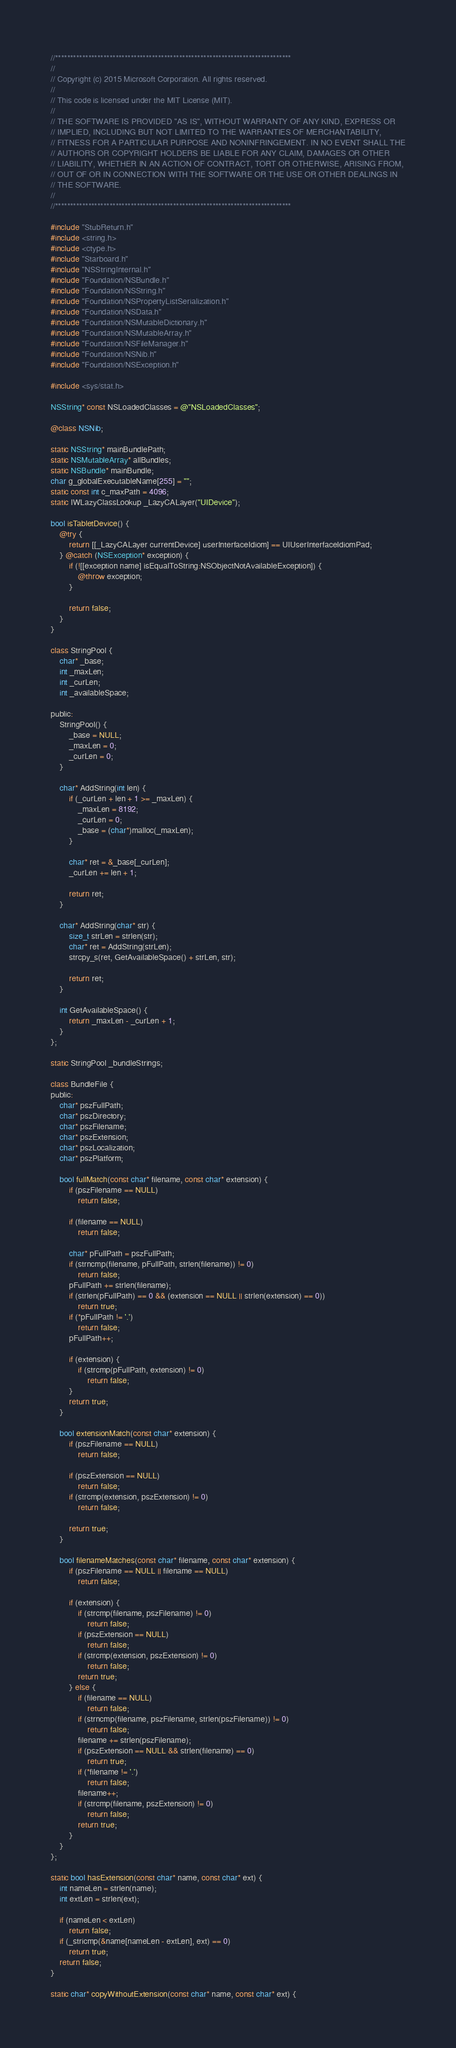Convert code to text. <code><loc_0><loc_0><loc_500><loc_500><_ObjectiveC_>//******************************************************************************
//
// Copyright (c) 2015 Microsoft Corporation. All rights reserved.
//
// This code is licensed under the MIT License (MIT).
//
// THE SOFTWARE IS PROVIDED "AS IS", WITHOUT WARRANTY OF ANY KIND, EXPRESS OR
// IMPLIED, INCLUDING BUT NOT LIMITED TO THE WARRANTIES OF MERCHANTABILITY,
// FITNESS FOR A PARTICULAR PURPOSE AND NONINFRINGEMENT. IN NO EVENT SHALL THE
// AUTHORS OR COPYRIGHT HOLDERS BE LIABLE FOR ANY CLAIM, DAMAGES OR OTHER
// LIABILITY, WHETHER IN AN ACTION OF CONTRACT, TORT OR OTHERWISE, ARISING FROM,
// OUT OF OR IN CONNECTION WITH THE SOFTWARE OR THE USE OR OTHER DEALINGS IN
// THE SOFTWARE.
//
//******************************************************************************

#include "StubReturn.h"
#include <string.h>
#include <ctype.h>
#include "Starboard.h"
#include "NSStringInternal.h"
#include "Foundation/NSBundle.h"
#include "Foundation/NSString.h"
#include "Foundation/NSPropertyListSerialization.h"
#include "Foundation/NSData.h"
#include "Foundation/NSMutableDictionary.h"
#include "Foundation/NSMutableArray.h"
#include "Foundation/NSFileManager.h"
#include "Foundation/NSNib.h"
#include "Foundation/NSException.h"

#include <sys/stat.h>

NSString* const NSLoadedClasses = @"NSLoadedClasses";

@class NSNib;

static NSString* mainBundlePath;
static NSMutableArray* allBundles;
static NSBundle* mainBundle;
char g_globalExecutableName[255] = "";
static const int c_maxPath = 4096;
static IWLazyClassLookup _LazyCALayer("UIDevice");

bool isTabletDevice() {
    @try {
        return [[_LazyCALayer currentDevice] userInterfaceIdiom] == UIUserInterfaceIdiomPad;
    } @catch (NSException* exception) {
        if (![[exception name] isEqualToString:NSObjectNotAvailableException]) {
            @throw exception;
        }

        return false;
    }
}

class StringPool {
    char* _base;
    int _maxLen;
    int _curLen;
    int _availableSpace;

public:
    StringPool() {
        _base = NULL;
        _maxLen = 0;
        _curLen = 0;
    }

    char* AddString(int len) {
        if (_curLen + len + 1 >= _maxLen) {
            _maxLen = 8192;
            _curLen = 0;
            _base = (char*)malloc(_maxLen);
        }

        char* ret = &_base[_curLen];
        _curLen += len + 1;

        return ret;
    }

    char* AddString(char* str) {
        size_t strLen = strlen(str);
        char* ret = AddString(strLen);
        strcpy_s(ret, GetAvailableSpace() + strLen, str);

        return ret;
    }

    int GetAvailableSpace() {
        return _maxLen - _curLen + 1;
    }
};

static StringPool _bundleStrings;

class BundleFile {
public:
    char* pszFullPath;
    char* pszDirectory;
    char* pszFilename;
    char* pszExtension;
    char* pszLocalization;
    char* pszPlatform;

    bool fullMatch(const char* filename, const char* extension) {
        if (pszFilename == NULL)
            return false;

        if (filename == NULL)
            return false;

        char* pFullPath = pszFullPath;
        if (strncmp(filename, pFullPath, strlen(filename)) != 0)
            return false;
        pFullPath += strlen(filename);
        if (strlen(pFullPath) == 0 && (extension == NULL || strlen(extension) == 0))
            return true;
        if (*pFullPath != '.')
            return false;
        pFullPath++;

        if (extension) {
            if (strcmp(pFullPath, extension) != 0)
                return false;
        }
        return true;
    }

    bool extensionMatch(const char* extension) {
        if (pszFilename == NULL)
            return false;

        if (pszExtension == NULL)
            return false;
        if (strcmp(extension, pszExtension) != 0)
            return false;

        return true;
    }

    bool filenameMatches(const char* filename, const char* extension) {
        if (pszFilename == NULL || filename == NULL)
            return false;

        if (extension) {
            if (strcmp(filename, pszFilename) != 0)
                return false;
            if (pszExtension == NULL)
                return false;
            if (strcmp(extension, pszExtension) != 0)
                return false;
            return true;
        } else {
            if (filename == NULL)
                return false;
            if (strncmp(filename, pszFilename, strlen(pszFilename)) != 0)
                return false;
            filename += strlen(pszFilename);
            if (pszExtension == NULL && strlen(filename) == 0)
                return true;
            if (*filename != '.')
                return false;
            filename++;
            if (strcmp(filename, pszExtension) != 0)
                return false;
            return true;
        }
    }
};

static bool hasExtension(const char* name, const char* ext) {
    int nameLen = strlen(name);
    int extLen = strlen(ext);

    if (nameLen < extLen)
        return false;
    if (_stricmp(&name[nameLen - extLen], ext) == 0)
        return true;
    return false;
}

static char* copyWithoutExtension(const char* name, const char* ext) {</code> 